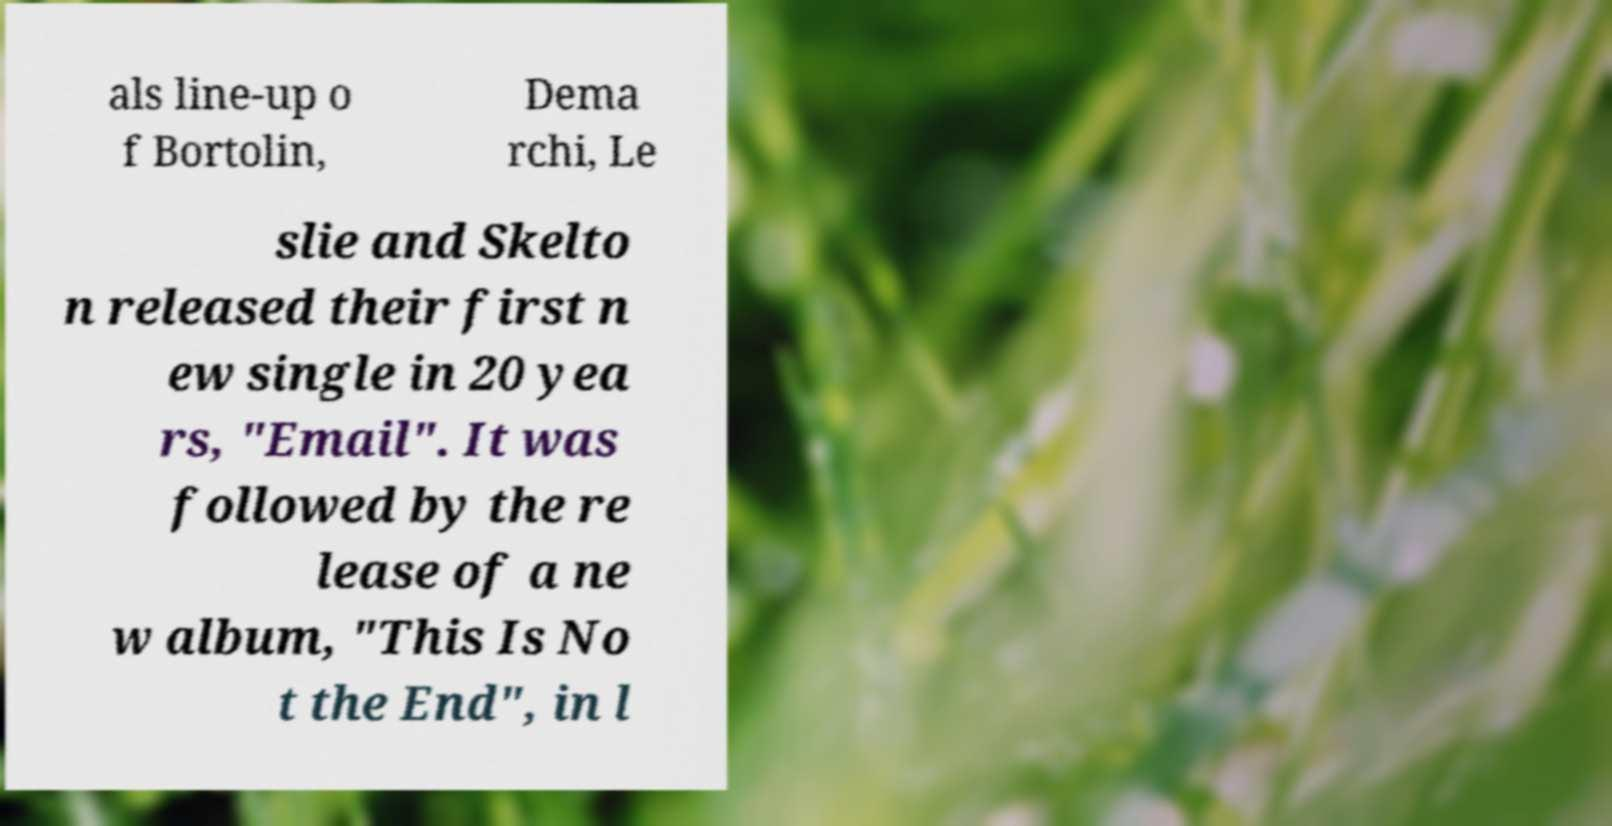What messages or text are displayed in this image? I need them in a readable, typed format. als line-up o f Bortolin, Dema rchi, Le slie and Skelto n released their first n ew single in 20 yea rs, "Email". It was followed by the re lease of a ne w album, "This Is No t the End", in l 